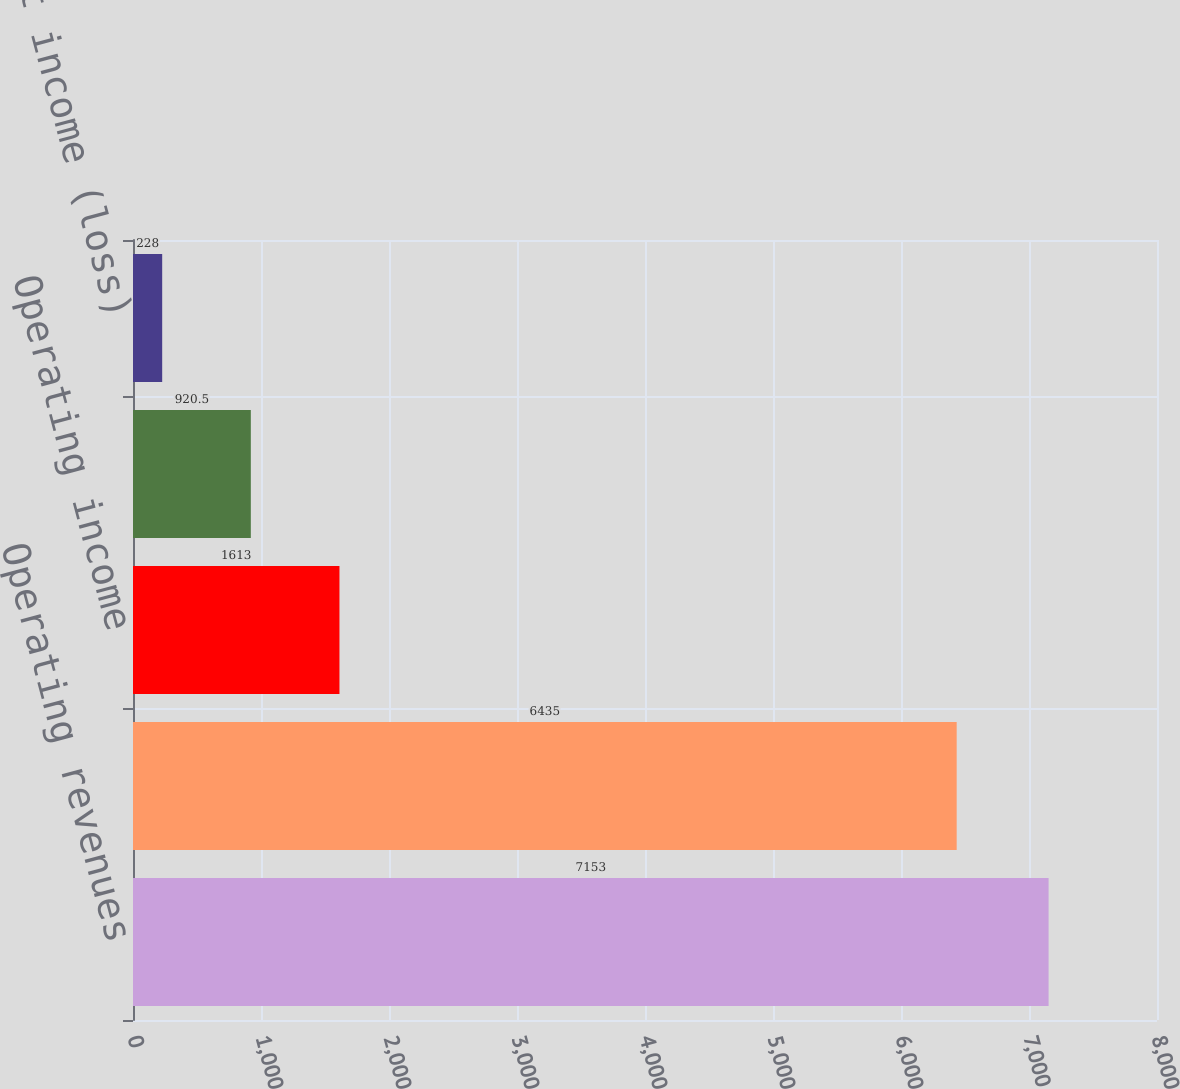Convert chart. <chart><loc_0><loc_0><loc_500><loc_500><bar_chart><fcel>Operating revenues<fcel>Operating expenses<fcel>Operating income<fcel>Net income<fcel>Net income (loss)<nl><fcel>7153<fcel>6435<fcel>1613<fcel>920.5<fcel>228<nl></chart> 